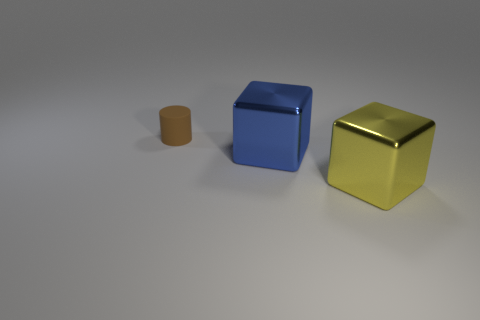Are there an equal number of big blue things that are left of the yellow cube and rubber things?
Ensure brevity in your answer.  Yes. The small matte cylinder is what color?
Your answer should be compact. Brown. What size is the object that is the same material as the big yellow cube?
Keep it short and to the point. Large. The big block that is the same material as the blue thing is what color?
Ensure brevity in your answer.  Yellow. Are there any other yellow objects that have the same size as the yellow shiny object?
Offer a very short reply. No. There is another object that is the same shape as the big yellow metallic thing; what is its material?
Your answer should be very brief. Metal. What shape is the metallic thing that is the same size as the blue metallic cube?
Your response must be concise. Cube. Is there a large yellow metallic object that has the same shape as the blue shiny thing?
Your answer should be very brief. Yes. What is the shape of the large shiny object that is on the right side of the cube behind the yellow block?
Offer a terse response. Cube. What is the shape of the big blue thing?
Provide a short and direct response. Cube. 